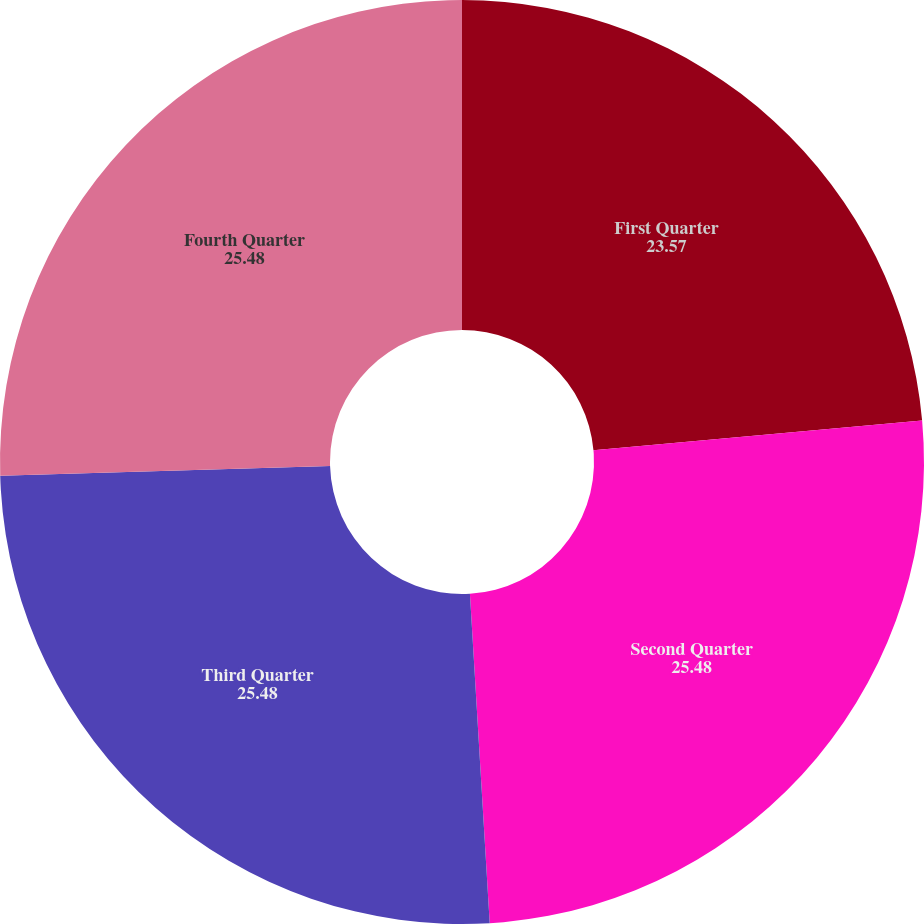Convert chart to OTSL. <chart><loc_0><loc_0><loc_500><loc_500><pie_chart><fcel>First Quarter<fcel>Second Quarter<fcel>Third Quarter<fcel>Fourth Quarter<nl><fcel>23.57%<fcel>25.48%<fcel>25.48%<fcel>25.48%<nl></chart> 